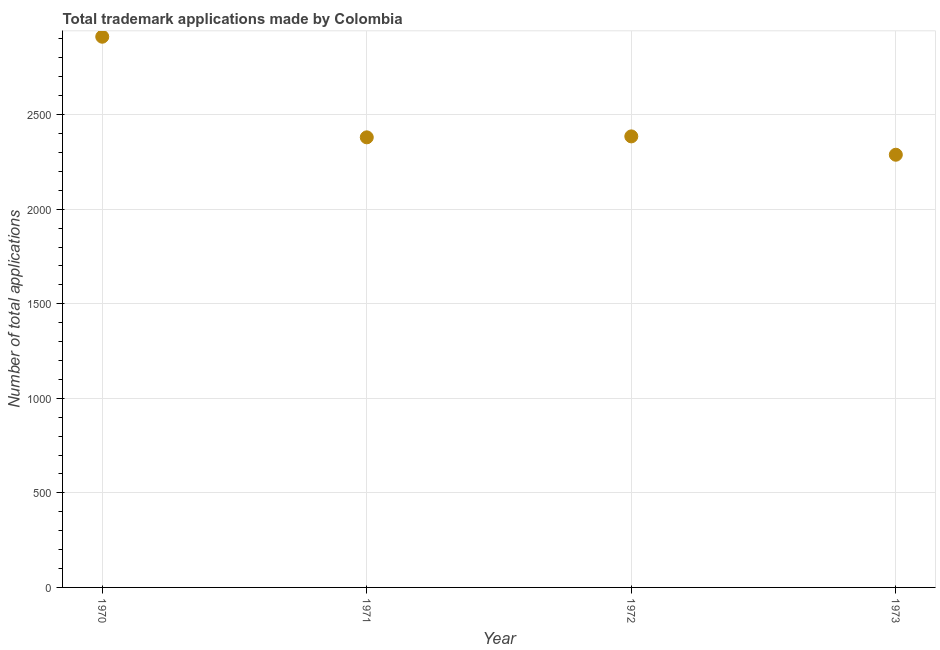What is the number of trademark applications in 1972?
Ensure brevity in your answer.  2385. Across all years, what is the maximum number of trademark applications?
Ensure brevity in your answer.  2912. Across all years, what is the minimum number of trademark applications?
Offer a very short reply. 2288. In which year was the number of trademark applications maximum?
Offer a very short reply. 1970. In which year was the number of trademark applications minimum?
Your response must be concise. 1973. What is the sum of the number of trademark applications?
Offer a terse response. 9965. What is the difference between the number of trademark applications in 1971 and 1972?
Provide a short and direct response. -5. What is the average number of trademark applications per year?
Provide a short and direct response. 2491.25. What is the median number of trademark applications?
Your answer should be compact. 2382.5. What is the ratio of the number of trademark applications in 1971 to that in 1972?
Your answer should be compact. 1. Is the difference between the number of trademark applications in 1971 and 1972 greater than the difference between any two years?
Provide a short and direct response. No. What is the difference between the highest and the second highest number of trademark applications?
Keep it short and to the point. 527. What is the difference between the highest and the lowest number of trademark applications?
Offer a terse response. 624. In how many years, is the number of trademark applications greater than the average number of trademark applications taken over all years?
Your response must be concise. 1. Does the number of trademark applications monotonically increase over the years?
Your answer should be compact. No. What is the difference between two consecutive major ticks on the Y-axis?
Give a very brief answer. 500. What is the title of the graph?
Ensure brevity in your answer.  Total trademark applications made by Colombia. What is the label or title of the X-axis?
Keep it short and to the point. Year. What is the label or title of the Y-axis?
Your answer should be compact. Number of total applications. What is the Number of total applications in 1970?
Ensure brevity in your answer.  2912. What is the Number of total applications in 1971?
Your answer should be very brief. 2380. What is the Number of total applications in 1972?
Offer a very short reply. 2385. What is the Number of total applications in 1973?
Make the answer very short. 2288. What is the difference between the Number of total applications in 1970 and 1971?
Provide a succinct answer. 532. What is the difference between the Number of total applications in 1970 and 1972?
Offer a terse response. 527. What is the difference between the Number of total applications in 1970 and 1973?
Offer a very short reply. 624. What is the difference between the Number of total applications in 1971 and 1972?
Ensure brevity in your answer.  -5. What is the difference between the Number of total applications in 1971 and 1973?
Offer a very short reply. 92. What is the difference between the Number of total applications in 1972 and 1973?
Ensure brevity in your answer.  97. What is the ratio of the Number of total applications in 1970 to that in 1971?
Offer a terse response. 1.22. What is the ratio of the Number of total applications in 1970 to that in 1972?
Your answer should be very brief. 1.22. What is the ratio of the Number of total applications in 1970 to that in 1973?
Offer a terse response. 1.27. What is the ratio of the Number of total applications in 1971 to that in 1973?
Provide a short and direct response. 1.04. What is the ratio of the Number of total applications in 1972 to that in 1973?
Your answer should be very brief. 1.04. 